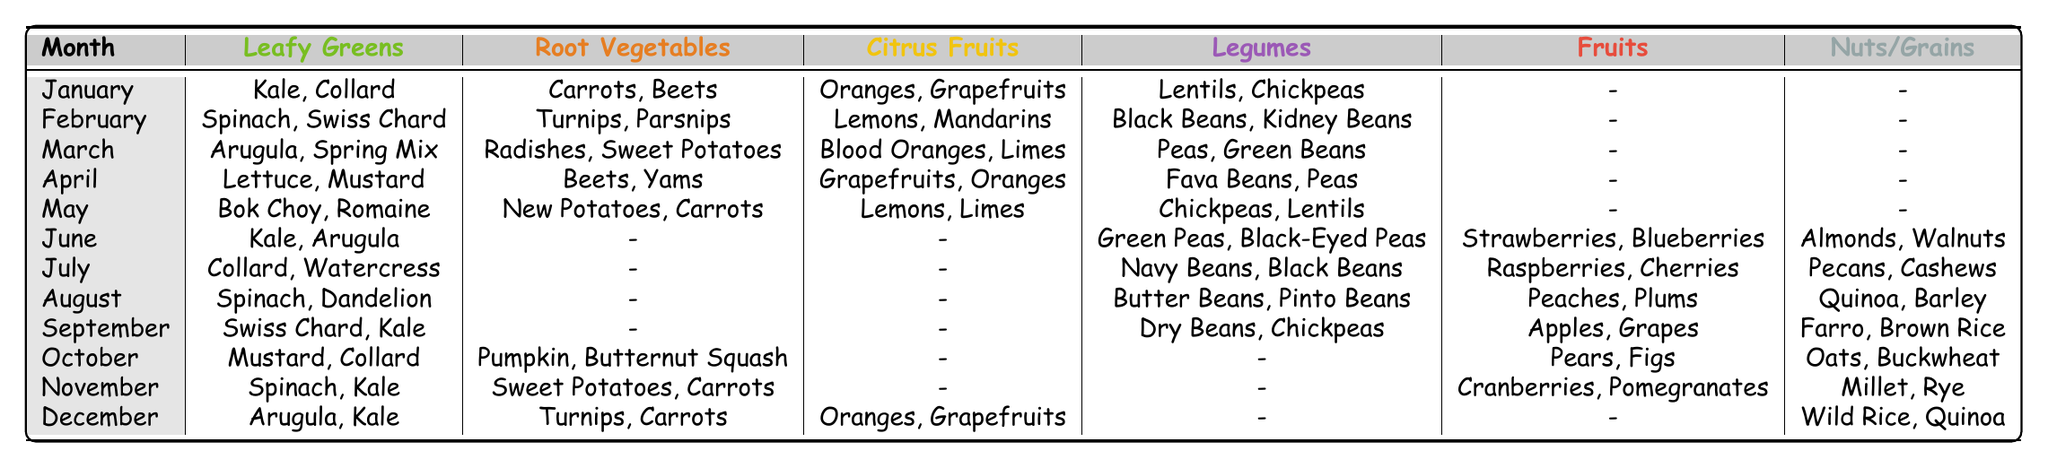What leafy greens are available in February? By referring to the table in the February row under the Leafy Greens column, we find that Spinach and Swiss Chard are listed.
Answer: Spinach, Swiss Chard How many types of legumes are available in June? In the June row, the Legumes column lists two types: Green Peas and Black-Eyed Peas. Thus, there are 2 types of legumes available.
Answer: 2 In which month are peaches available? Looking through the Fruits column, we find that Peaches are listed under the month of August.
Answer: August Are there any root vegetables available in July? The July row in the Root Vegetables column shows a dash, indicating that there are no root vegetables available in that month. Therefore, the answer is no.
Answer: No Which month has the most types of vegetables available, counting Leafy Greens, Root Vegetables, and Legumes? By checking the availability listed for each month, we count the types for each row: January (4), February (4), March (4), April (4), May (4), June (2), July (2), August (2), September (2), October (3), November (3), December (3). January, February, March, April, May all have the highest count of 4 types of vegetables available.
Answer: January, February, March, April, May What is the total number of fruits available in October and December combined? In the October row, there are 2 fruits (Pears, Figs) and in December, there are also 2 fruits (Oranges, Grapefruits). Adding them together gives us a total of 2 + 2 = 4 fruits.
Answer: 4 Do any months have both nuts and legumes listed? Upon examining the table, June and July are the only months that list Nuts (Almonds, Walnuts) and Legumes (Green Peas, Black-Eyed Peas; Navy Beans, Black Beans respectively). Therefore, the answer is yes.
Answer: Yes Which type of vegetable is available in both September and November? In September, the "Legumes" column shows Dry Beans, Chickpeas, and in November shows Sweet Potatoes, Carrots. We don't find a matching vegetable in both months. Hence, there is none available in both months.
Answer: None 